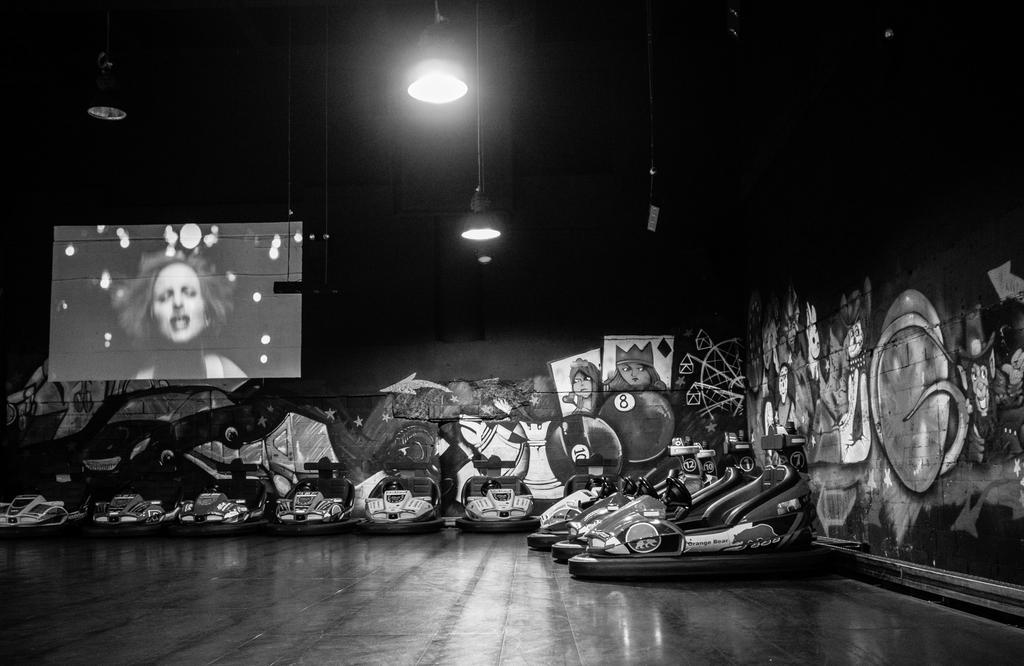What is the color scheme of the image? The image is black and white. What types of objects can be seen in the image? There are vehicles and lights visible in the image. What is the purpose of the screen in the image? The purpose of the screen in the image is not specified, but it could be for displaying information or images. What type of artwork is present in the background of the image? There are paintings on the walls in the background of the image. What type of meat is being served at the scene in the image? There is no scene or meat present in the image; it is a black and white image featuring vehicles, lights, a screen, and paintings on the walls. 